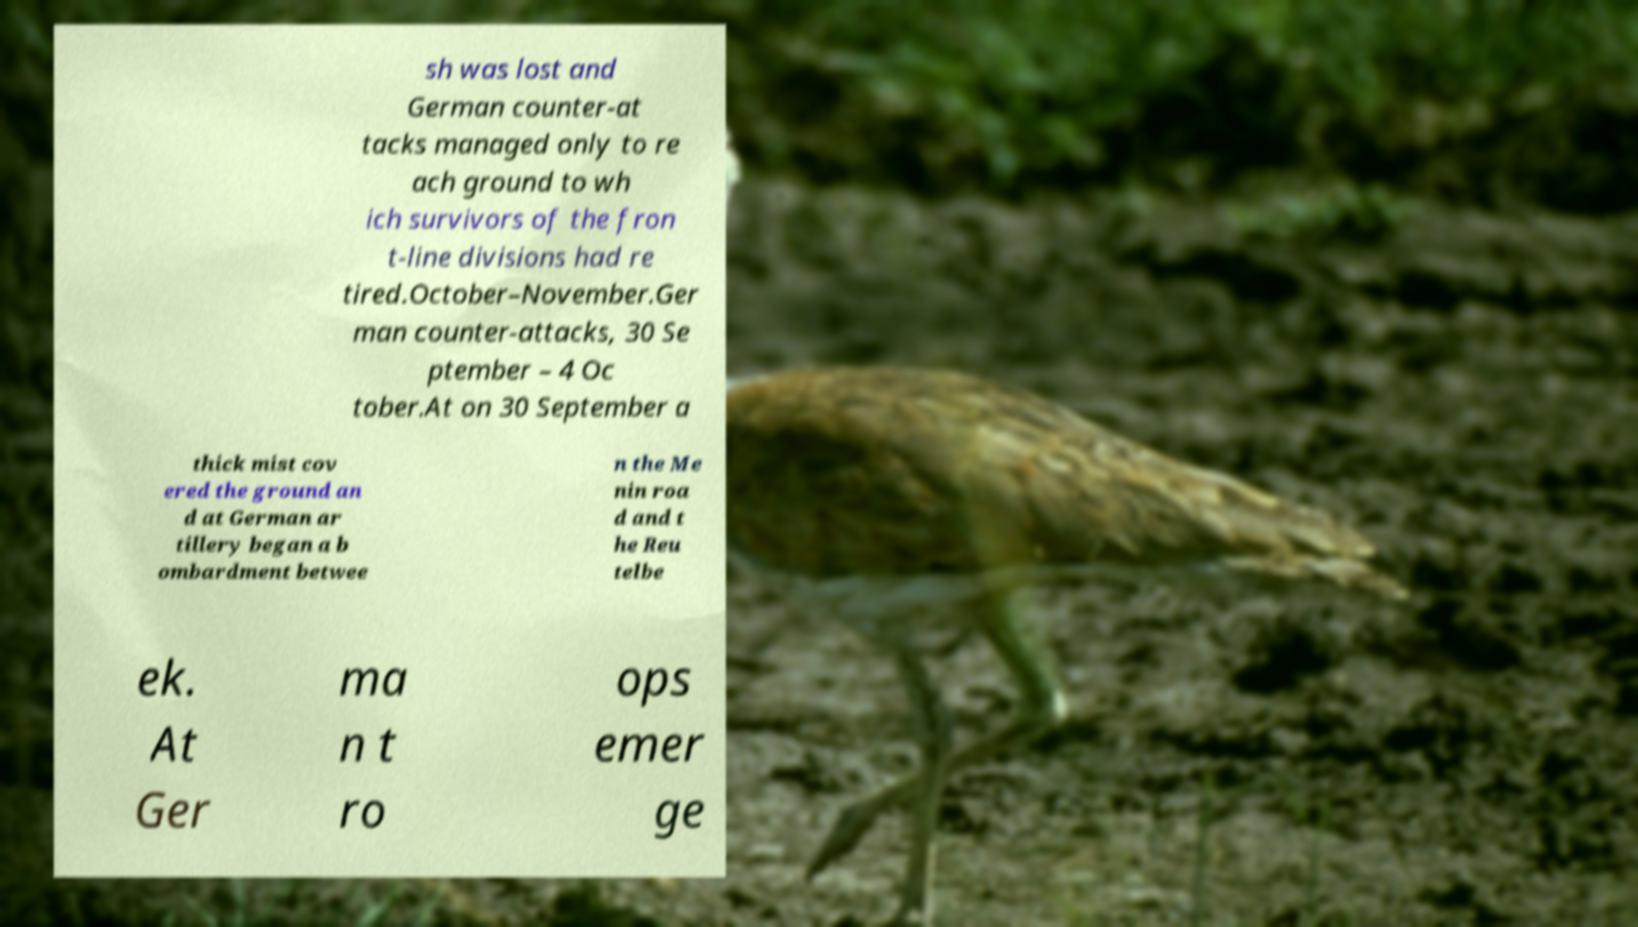Could you assist in decoding the text presented in this image and type it out clearly? sh was lost and German counter-at tacks managed only to re ach ground to wh ich survivors of the fron t-line divisions had re tired.October–November.Ger man counter-attacks, 30 Se ptember – 4 Oc tober.At on 30 September a thick mist cov ered the ground an d at German ar tillery began a b ombardment betwee n the Me nin roa d and t he Reu telbe ek. At Ger ma n t ro ops emer ge 